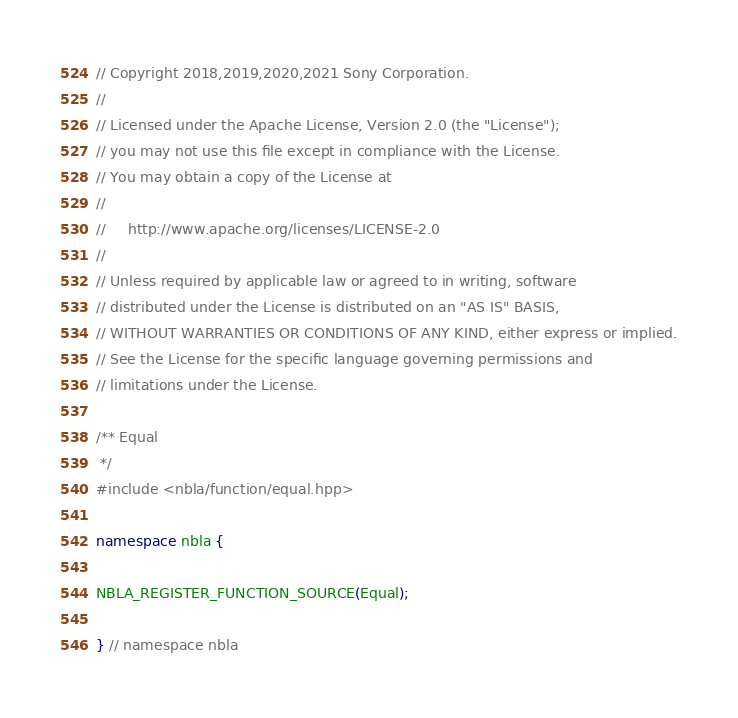<code> <loc_0><loc_0><loc_500><loc_500><_C++_>// Copyright 2018,2019,2020,2021 Sony Corporation.
//
// Licensed under the Apache License, Version 2.0 (the "License");
// you may not use this file except in compliance with the License.
// You may obtain a copy of the License at
//
//     http://www.apache.org/licenses/LICENSE-2.0
//
// Unless required by applicable law or agreed to in writing, software
// distributed under the License is distributed on an "AS IS" BASIS,
// WITHOUT WARRANTIES OR CONDITIONS OF ANY KIND, either express or implied.
// See the License for the specific language governing permissions and
// limitations under the License.

/** Equal
 */
#include <nbla/function/equal.hpp>

namespace nbla {

NBLA_REGISTER_FUNCTION_SOURCE(Equal);

} // namespace nbla
</code> 